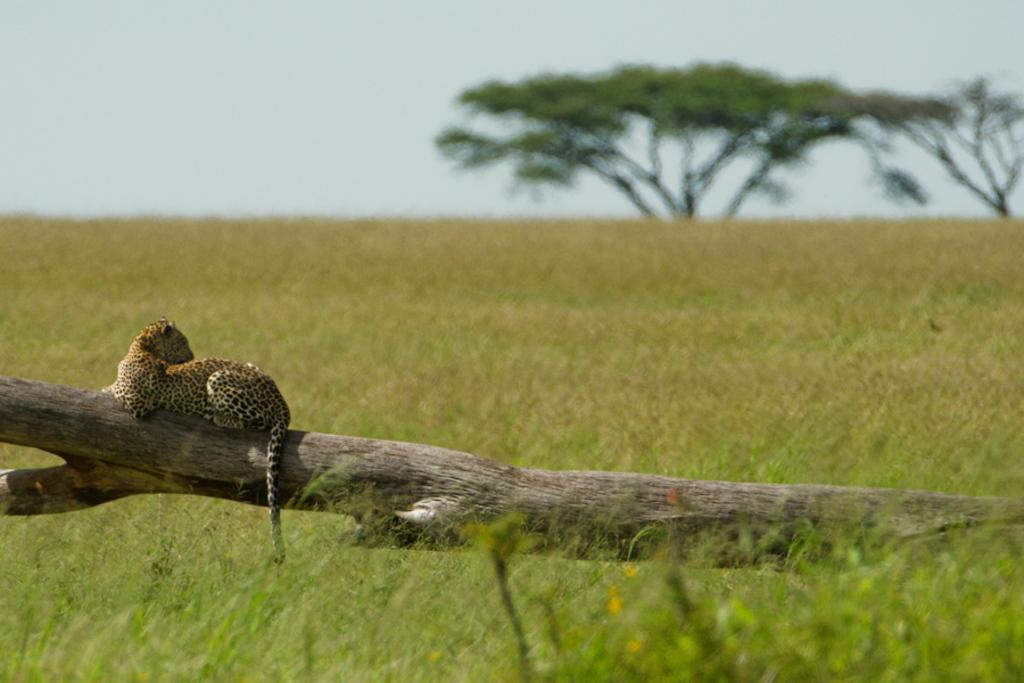In one or two sentences, can you explain what this image depicts? In this picture we can observe a cheetah sitting on the log of a tree. There is some grass on the ground. In the background there are trees and a sky. 